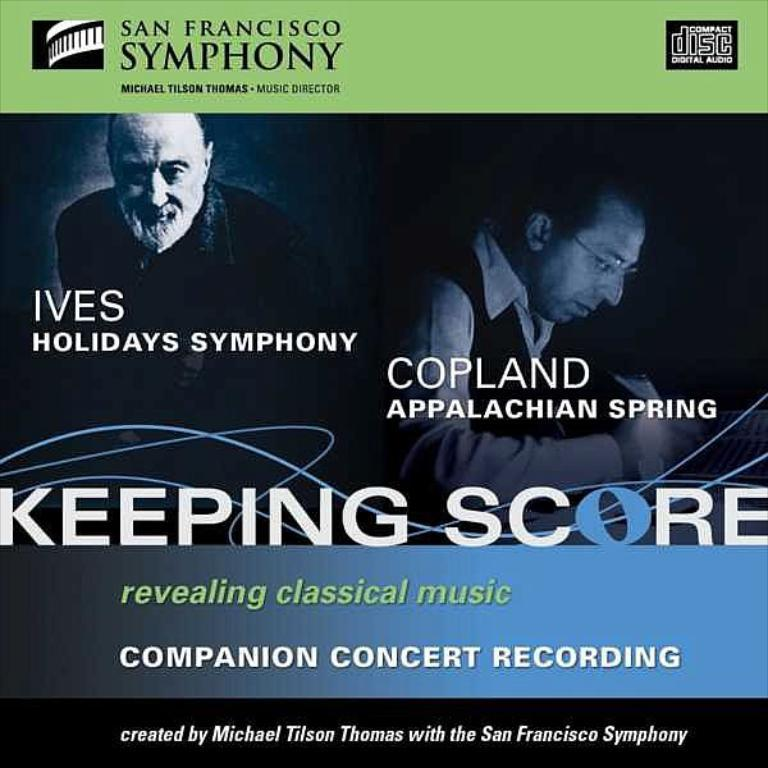What is present in the image that features visual content? There is a poster in the image. What can be seen on the poster? The poster contains images of two people. Are there any words or phrases on the poster? Yes, there is written matter on the poster. How many beans are visible on the poster in the image? There are no beans present on the poster in the image. What color are the eyes of the people depicted on the poster? There is no information about the eye color of the people depicted on the poster, as the facts provided do not mention it. 